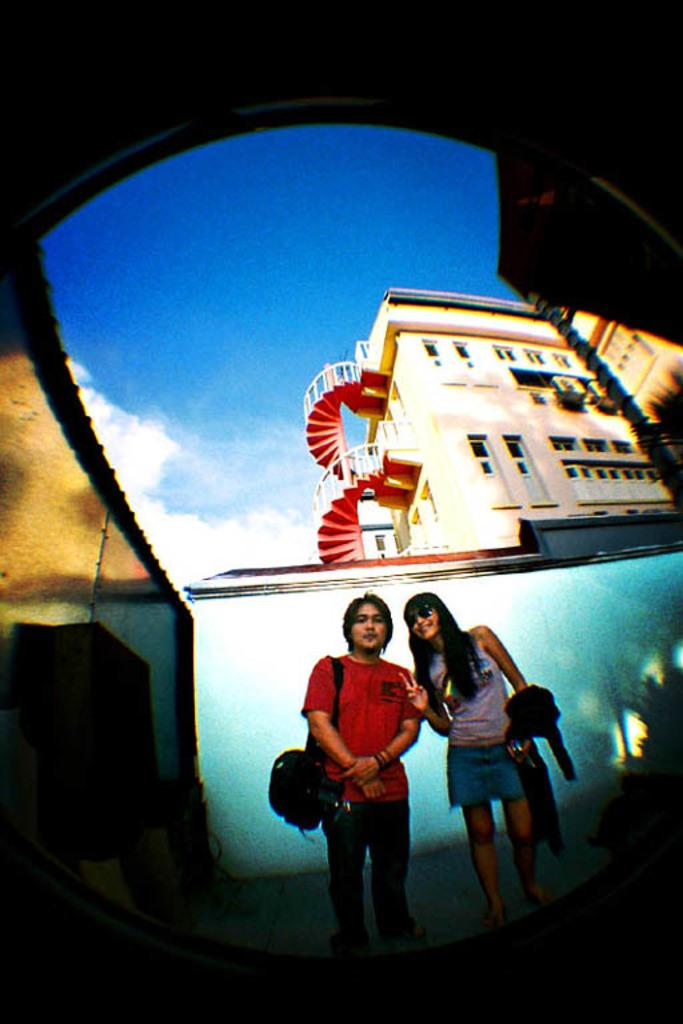How many people are present in the image? There are two persons standing in the image. What can be seen in the background of the image? There is a building and the sky visible in the background of the image. What type of insurance policy do the pets in the image have? There are no pets present in the image, so it is not possible to determine what type of insurance policy they might have. 